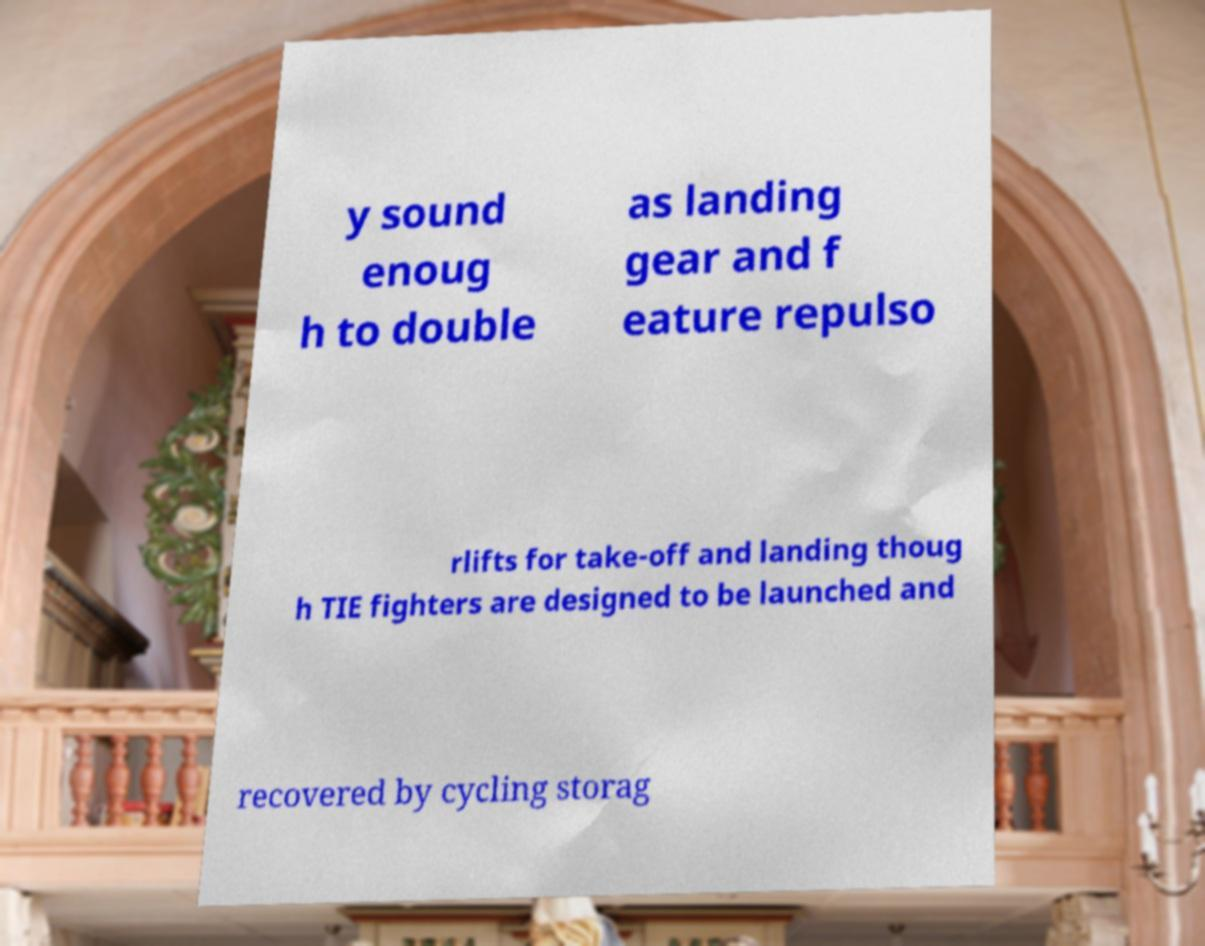Could you extract and type out the text from this image? y sound enoug h to double as landing gear and f eature repulso rlifts for take-off and landing thoug h TIE fighters are designed to be launched and recovered by cycling storag 